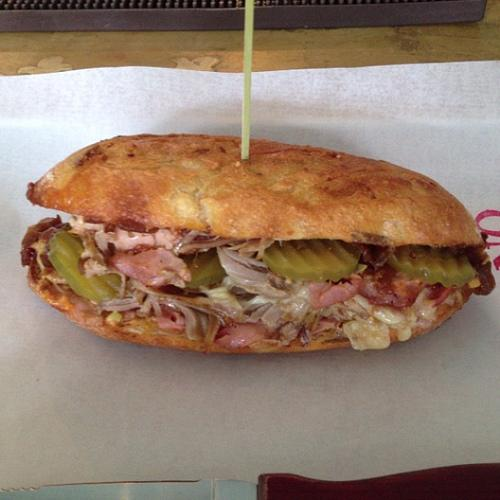Describe the toothpick present in the sandwich. A skinny mint green toothpick is used to hold the contents of the sub. Count the number of pickles in the sub. There are a couple of pickles in the sub. What are some ingredients present in the sandwich? Meat, pickles, onions, melted cheese, ham, and pulled pork are some ingredients in the sandwich. What type of paper is the sandwich sitting on? The sandwich sits on white wax food paper. Offer a brief depiction on the object interaction of the toothpick and the sandwich. The toothpick is inserted into the sandwich, holding its contents together. Identify the main object in the image. An amazing looking sandwich with several ingredients like pickles and meat. What color are the pickles in the sandwich, and do they have any particular characteristics? The pickles are green in color and have crinkles in them. Share details about the bread in the sandwich. The bread is a golden brown color, lightly toasted with a top and bottom layer. What kind of sandwich is depicted in the image? A toasted cuban sandwich with pork, ham, cheese, and pickles fills the image. Provide a comprehensive description of the knife near the sandwich. A wood and metal knife with a brown wooden handle and a sharp blade lies near the sandwich. 